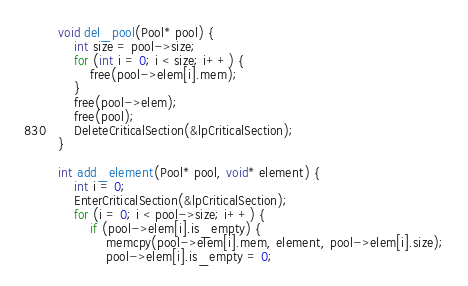Convert code to text. <code><loc_0><loc_0><loc_500><loc_500><_C_>void del_pool(Pool* pool) {
	int size = pool->size;
	for (int i = 0; i < size; i++) {
		free(pool->elem[i].mem);
	}
	free(pool->elem);
	free(pool);
	DeleteCriticalSection(&lpCriticalSection);
}

int add_element(Pool* pool, void* element) {
	int i = 0;
	EnterCriticalSection(&lpCriticalSection);
	for (i = 0; i < pool->size; i++) {
		if (pool->elem[i].is_empty) {
			memcpy(pool->elem[i].mem, element, pool->elem[i].size);
			pool->elem[i].is_empty = 0;</code> 